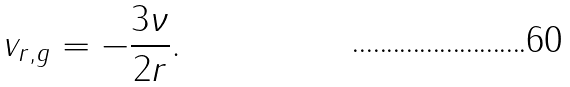Convert formula to latex. <formula><loc_0><loc_0><loc_500><loc_500>v _ { r , g } = - \frac { 3 \nu } { 2 r } .</formula> 